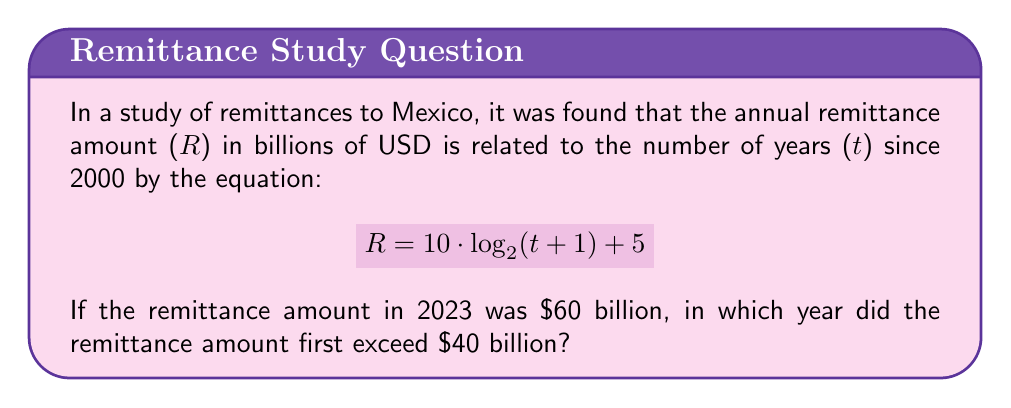Give your solution to this math problem. To solve this problem, we'll follow these steps:

1) First, we need to find t when R = $40 billion:

   $$40 = 10 \cdot \log_2(t+1) + 5$$

2) Subtract 5 from both sides:

   $$35 = 10 \cdot \log_2(t+1)$$

3) Divide both sides by 10:

   $$3.5 = \log_2(t+1)$$

4) Apply $2^x$ to both sides:

   $$2^{3.5} = t+1$$

5) Calculate $2^{3.5}$:

   $$11.31 \approx t+1$$

6) Subtract 1 from both sides:

   $$10.31 \approx t$$

7) Since t represents the number of years since 2000, we add this to 2000:

   $$2000 + 10.31 \approx 2010.31$$

8) As we're looking for the first year it exceeded $40 billion, we round up to the next whole year:

   2011

9) To verify, we can check if 2010 would have exceeded $40 billion:
   
   For 2010, t = 10
   $$R = 10 \cdot \log_2(10+1) + 5 = 10 \cdot \log_2(11) + 5 \approx 39.93$$

   This confirms 2011 is the correct answer.
Answer: 2011 